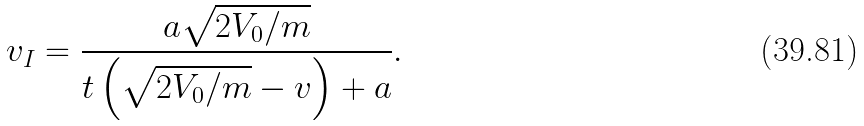<formula> <loc_0><loc_0><loc_500><loc_500>v _ { I } = \frac { a \sqrt { 2 V _ { 0 } / m } } { t \left ( \sqrt { 2 V _ { 0 } / m } - v \right ) + a } .</formula> 